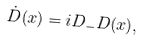<formula> <loc_0><loc_0><loc_500><loc_500>\dot { D } ( x ) = i D _ { - } D ( x ) ,</formula> 